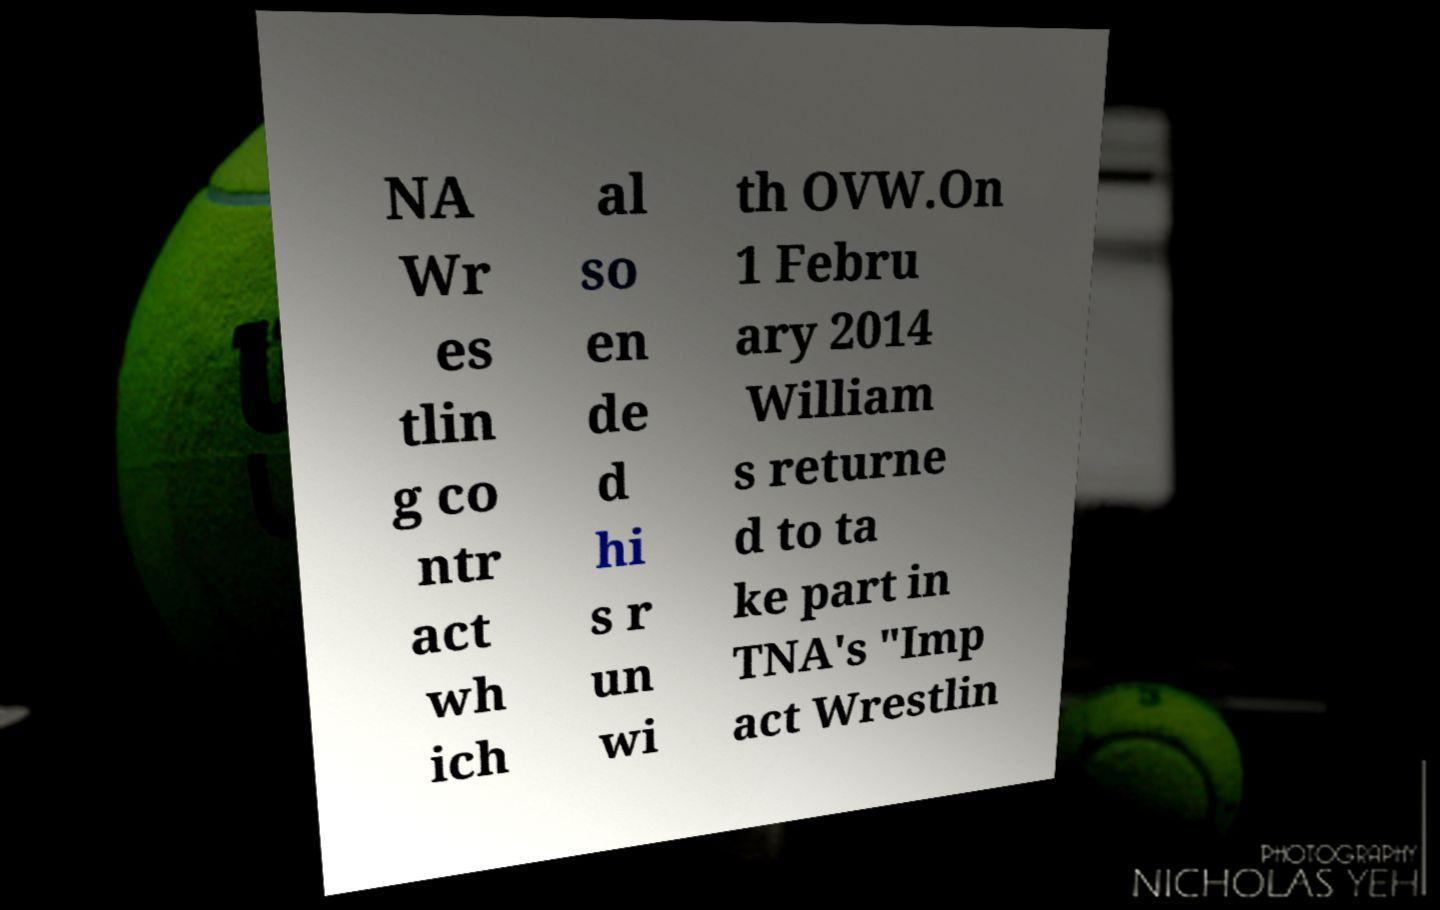Please read and relay the text visible in this image. What does it say? NA Wr es tlin g co ntr act wh ich al so en de d hi s r un wi th OVW.On 1 Febru ary 2014 William s returne d to ta ke part in TNA's "Imp act Wrestlin 